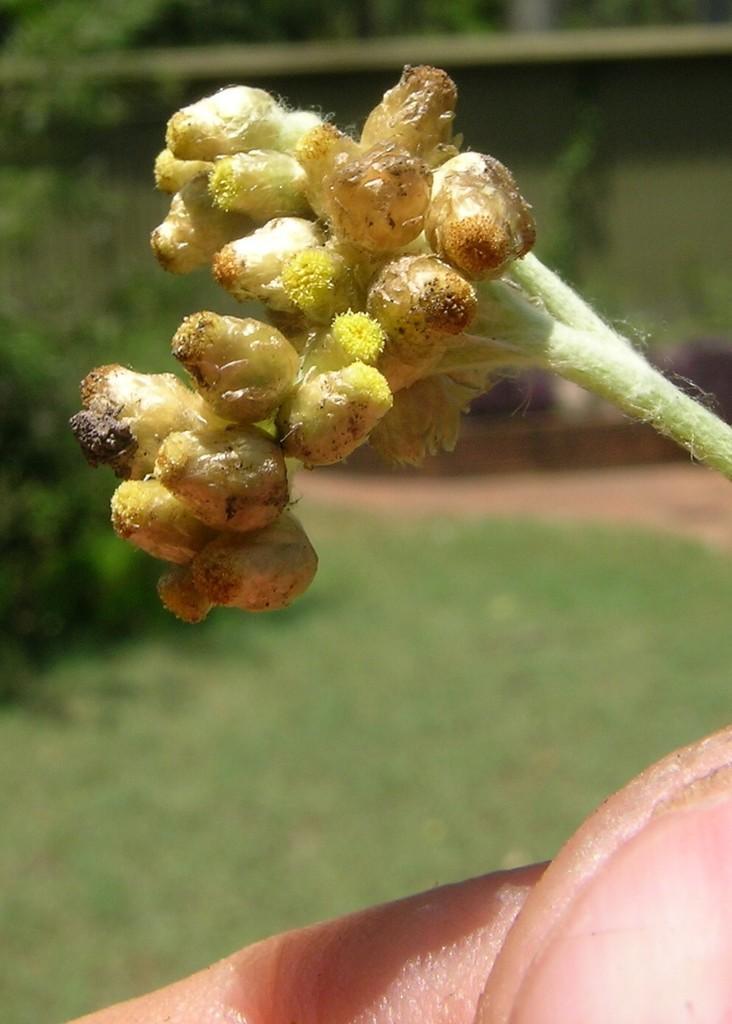Can you describe this image briefly? In this image we can able to see a human is holding a plant. Far there is a grass and plants. 